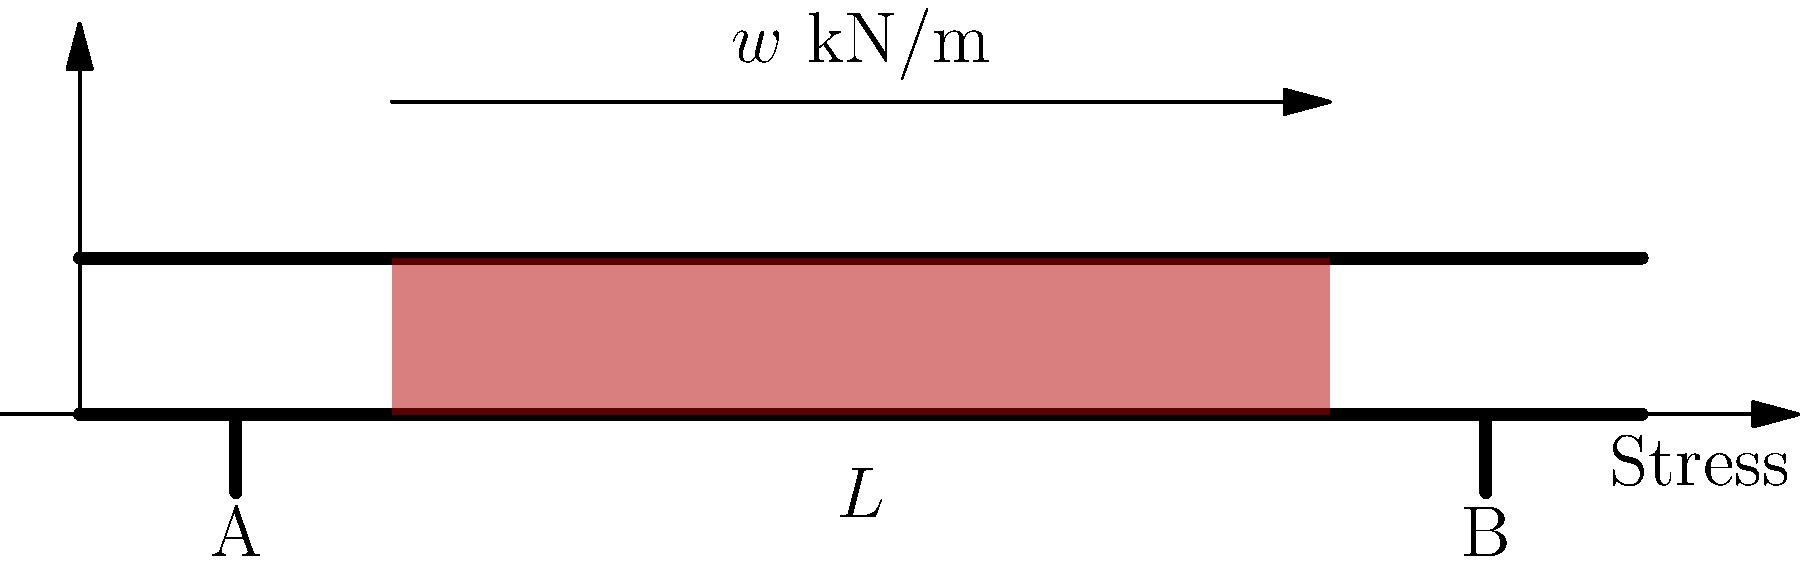In a simply supported reinforced concrete beam subjected to a uniformly distributed load $w$ kN/m, as shown in the figure, how does the maximum bending stress in the beam relate to its length $L$ and cross-sectional properties? Assume linear elastic behavior and that the beam's self-weight is negligible compared to the applied load. To determine the relationship between maximum bending stress, beam length, and cross-sectional properties, we'll follow these steps:

1) The maximum bending moment $M_{max}$ occurs at the center of the beam for a uniformly distributed load:

   $$M_{max} = \frac{wL^2}{8}$$

2) The bending stress $\sigma$ at any point in the beam is given by the flexure formula:

   $$\sigma = \frac{My}{I}$$

   where $M$ is the bending moment, $y$ is the distance from the neutral axis, and $I$ is the moment of inertia of the cross-section.

3) The maximum bending stress $\sigma_{max}$ occurs at the extreme fibers of the beam, where $y$ is maximum (let's call it $c$, half the beam depth):

   $$\sigma_{max} = \frac{M_{max}c}{I}$$

4) Substituting $M_{max}$ from step 1:

   $$\sigma_{max} = \frac{wL^2c}{8I}$$

5) The term $\frac{I}{c}$ is known as the section modulus $S$. Therefore:

   $$\sigma_{max} = \frac{wL^2}{8S}$$

This equation shows that the maximum bending stress is:
- Directly proportional to the square of the beam length $L^2$
- Directly proportional to the distributed load $w$
- Inversely proportional to the section modulus $S$

For a given load and beam length, increasing the section modulus (which depends on the beam's cross-sectional shape and size) will decrease the maximum stress.
Answer: $$\sigma_{max} = \frac{wL^2}{8S}$$ 